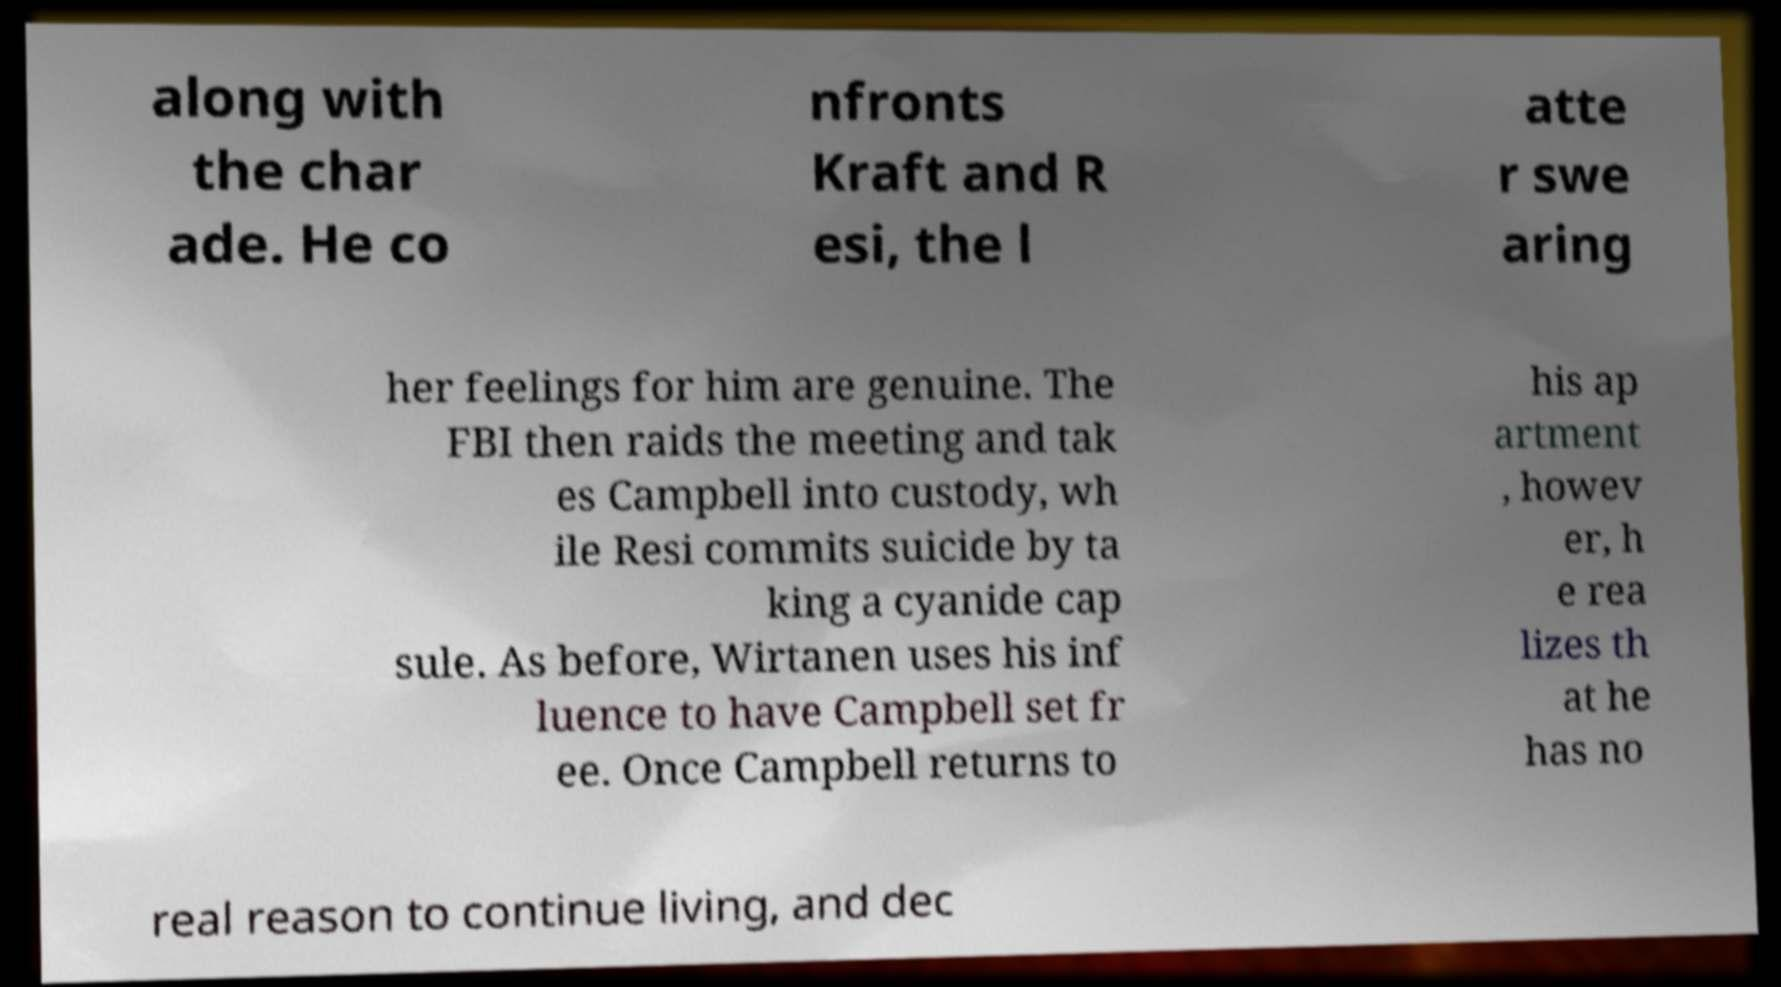Please read and relay the text visible in this image. What does it say? along with the char ade. He co nfronts Kraft and R esi, the l atte r swe aring her feelings for him are genuine. The FBI then raids the meeting and tak es Campbell into custody, wh ile Resi commits suicide by ta king a cyanide cap sule. As before, Wirtanen uses his inf luence to have Campbell set fr ee. Once Campbell returns to his ap artment , howev er, h e rea lizes th at he has no real reason to continue living, and dec 